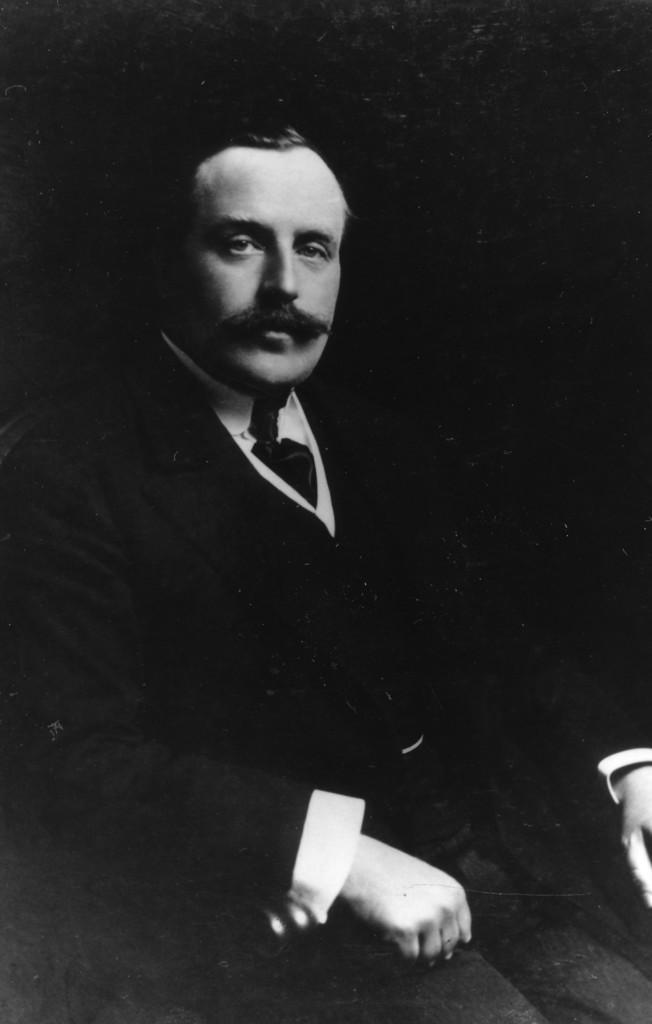Could you give a brief overview of what you see in this image? In this image we can see a photo of a person and we can also see a dark background. 